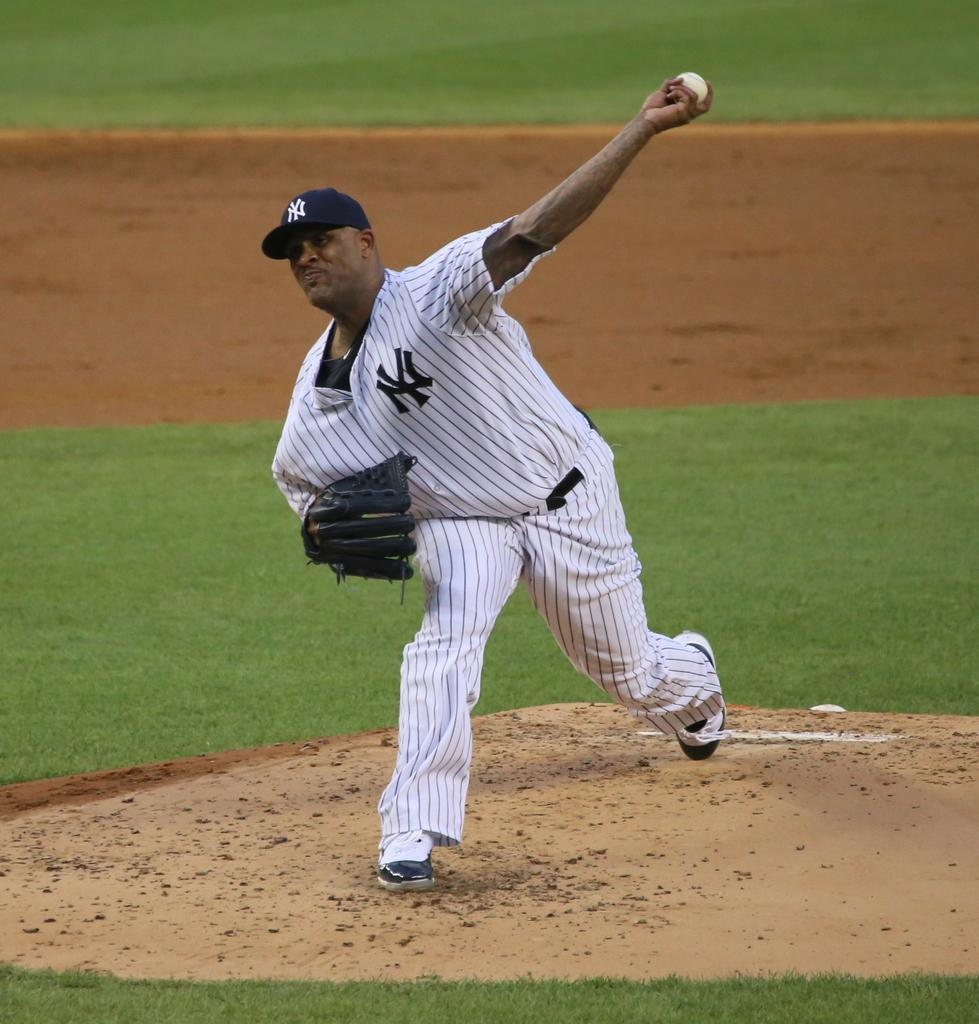Who is present in the image? There is a man in the image. What is the man doing in the image? The man is playing on the ground. What accessories is the man wearing in the image? The man is wearing a cap and a glove. What object is the man holding in the image? The man is holding a ball with his hand. What type of surface is visible in the image? There is grass visible in the image. What type of list can be seen in the image? There is no list present in the image. What color is the patch on the man's glove? The provided facts do not mention a patch on the man's glove, so we cannot determine its color. 